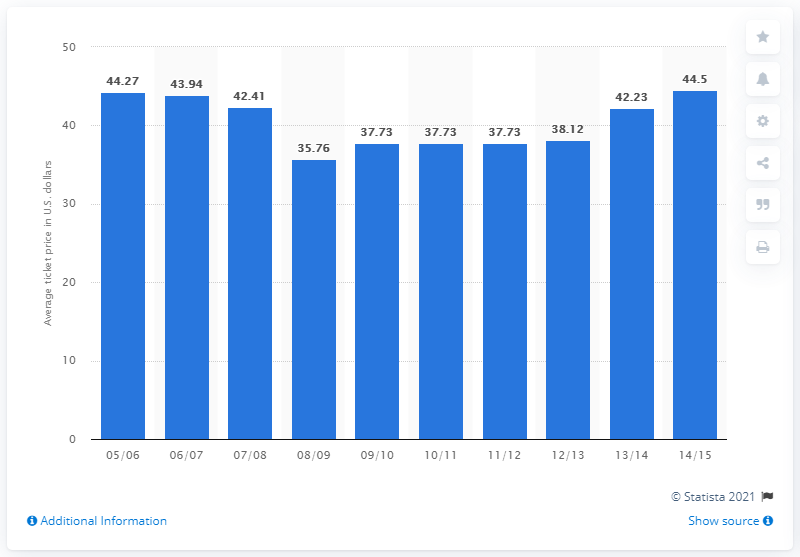Give some essential details in this illustration. The average ticket price in the 2005/06 season was 44.27. 